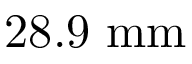Convert formula to latex. <formula><loc_0><loc_0><loc_500><loc_500>2 8 . 9 \ m m</formula> 